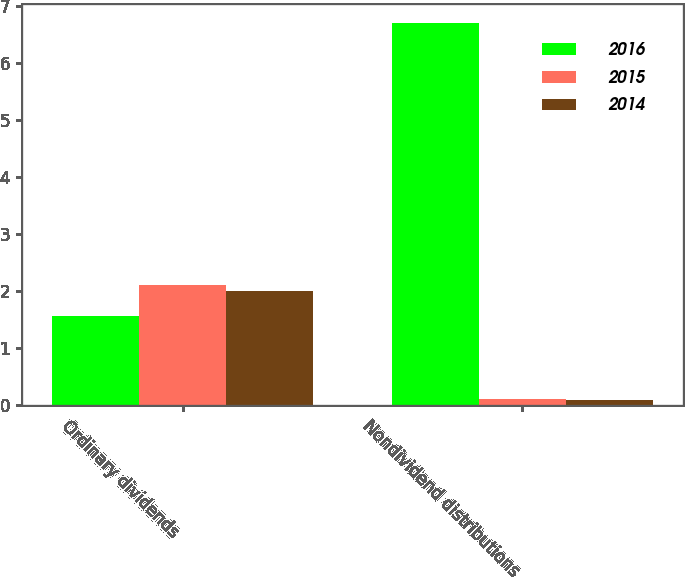Convert chart. <chart><loc_0><loc_0><loc_500><loc_500><stacked_bar_chart><ecel><fcel>Ordinary dividends<fcel>Nondividend distributions<nl><fcel>2016<fcel>1.56<fcel>6.71<nl><fcel>2015<fcel>2.12<fcel>0.11<nl><fcel>2014<fcel>2<fcel>0.09<nl></chart> 